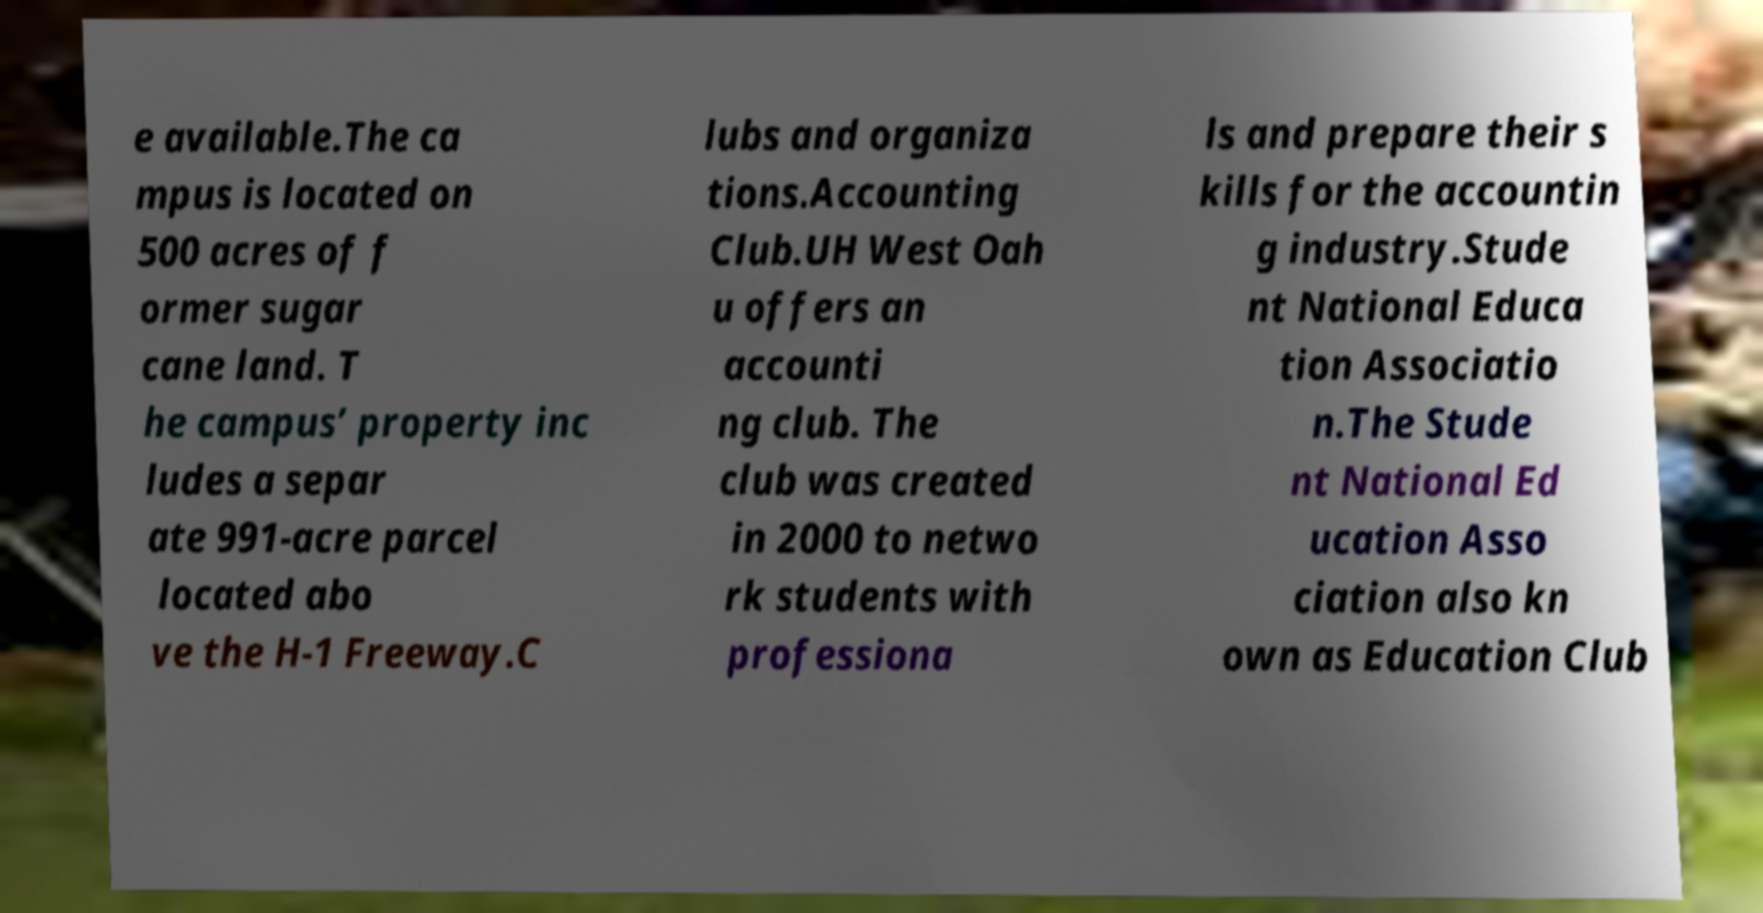Can you read and provide the text displayed in the image?This photo seems to have some interesting text. Can you extract and type it out for me? e available.The ca mpus is located on 500 acres of f ormer sugar cane land. T he campus’ property inc ludes a separ ate 991-acre parcel located abo ve the H-1 Freeway.C lubs and organiza tions.Accounting Club.UH West Oah u offers an accounti ng club. The club was created in 2000 to netwo rk students with professiona ls and prepare their s kills for the accountin g industry.Stude nt National Educa tion Associatio n.The Stude nt National Ed ucation Asso ciation also kn own as Education Club 